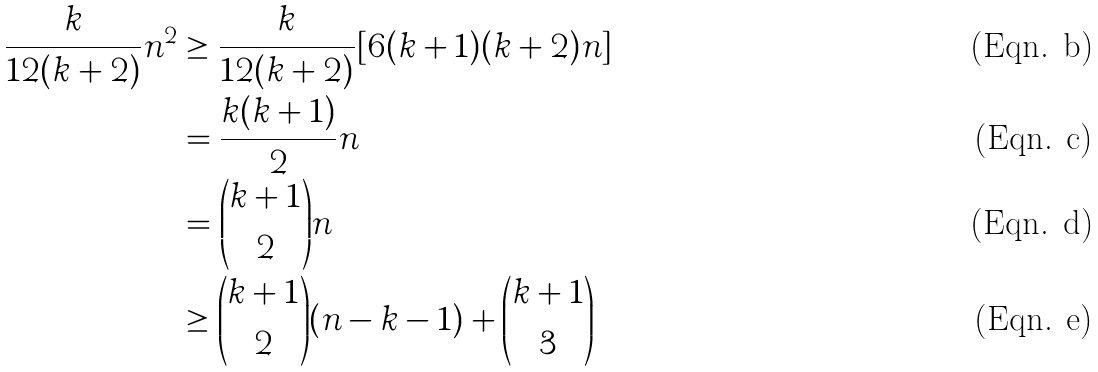Convert formula to latex. <formula><loc_0><loc_0><loc_500><loc_500>\frac { k } { 1 2 ( k + 2 ) } n ^ { 2 } & \geq \frac { k } { 1 2 ( k + 2 ) } [ 6 ( k + 1 ) ( k + 2 ) n ] \\ & = \frac { k ( k + 1 ) } { 2 } n \\ & = \binom { k + 1 } { 2 } n \\ & \geq \binom { k + 1 } { 2 } ( n - k - 1 ) + \binom { k + 1 } { 3 }</formula> 